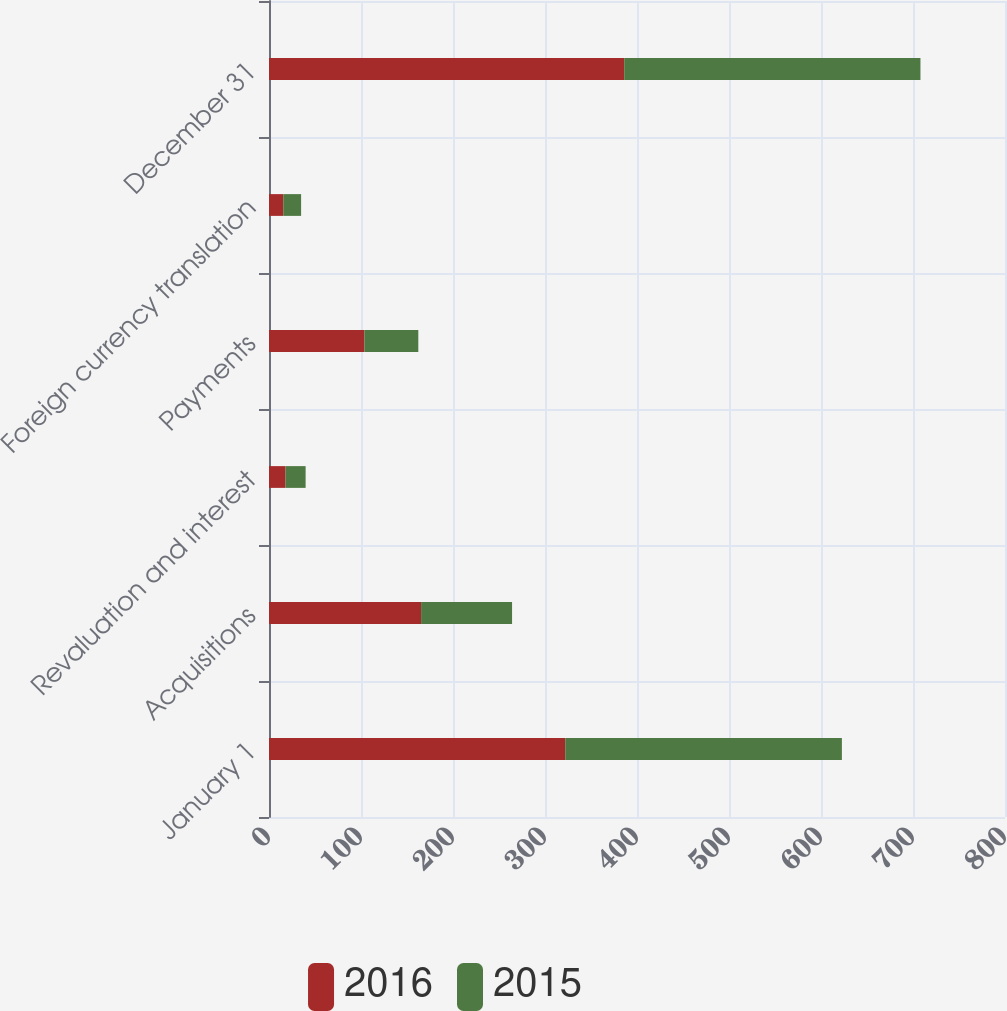Convert chart to OTSL. <chart><loc_0><loc_0><loc_500><loc_500><stacked_bar_chart><ecel><fcel>January 1<fcel>Acquisitions<fcel>Revaluation and interest<fcel>Payments<fcel>Foreign currency translation<fcel>December 31<nl><fcel>2016<fcel>322<fcel>165.3<fcel>18<fcel>103.7<fcel>15.5<fcel>386.1<nl><fcel>2015<fcel>300.7<fcel>98.9<fcel>21.8<fcel>58.6<fcel>19.4<fcel>322<nl></chart> 